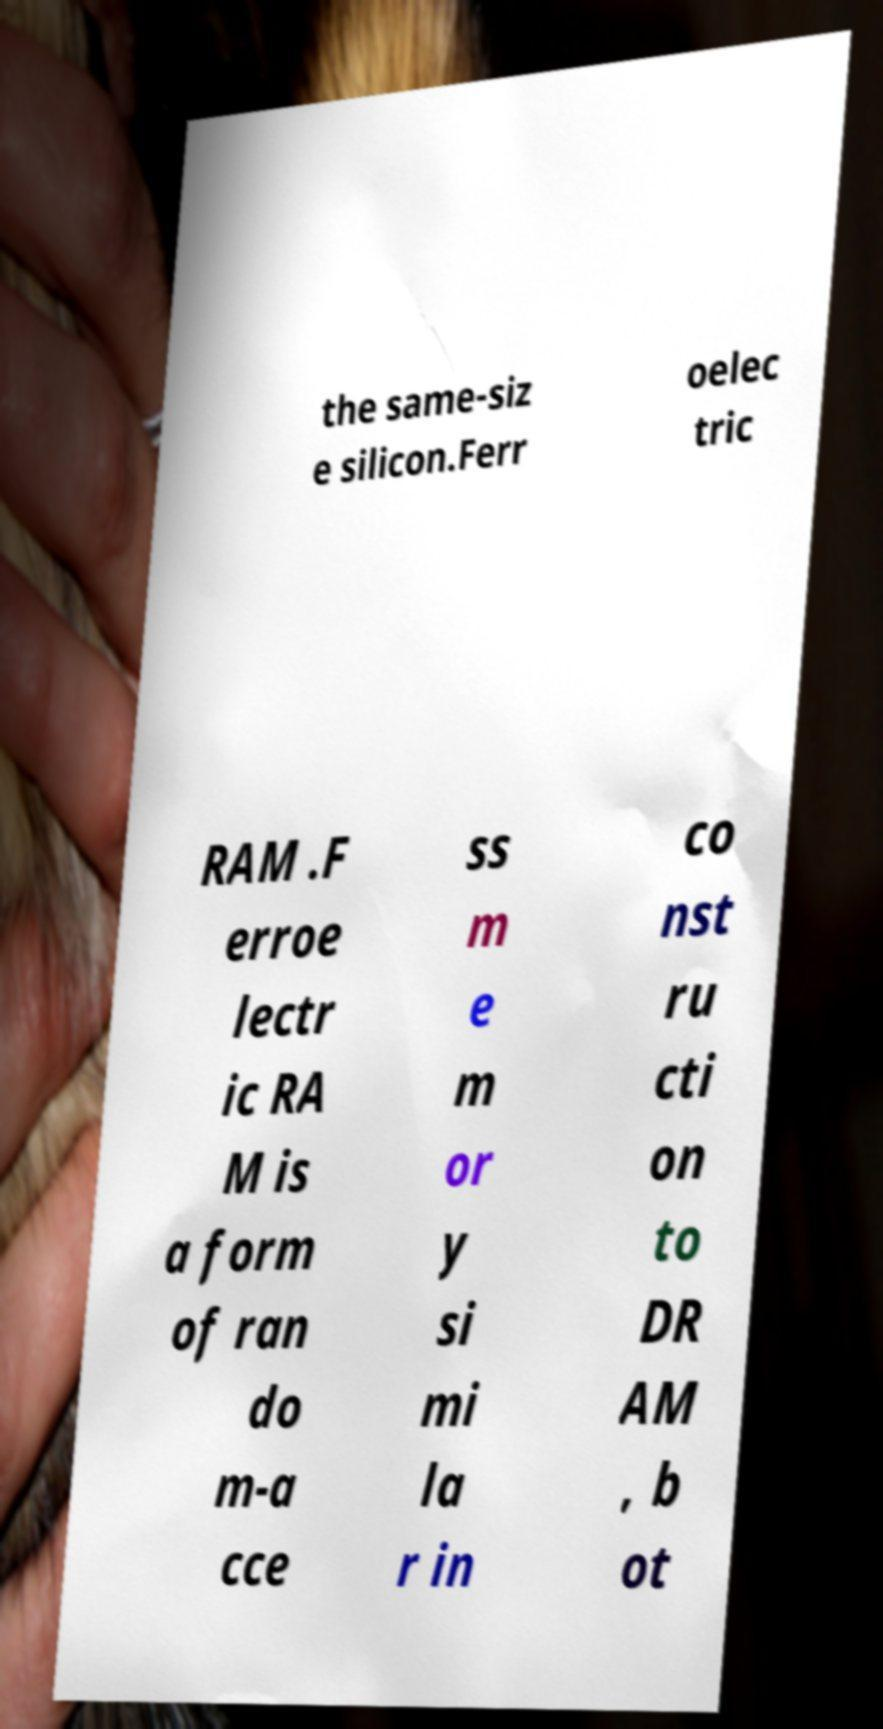Please identify and transcribe the text found in this image. the same-siz e silicon.Ferr oelec tric RAM .F erroe lectr ic RA M is a form of ran do m-a cce ss m e m or y si mi la r in co nst ru cti on to DR AM , b ot 